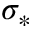<formula> <loc_0><loc_0><loc_500><loc_500>\sigma _ { \ast }</formula> 